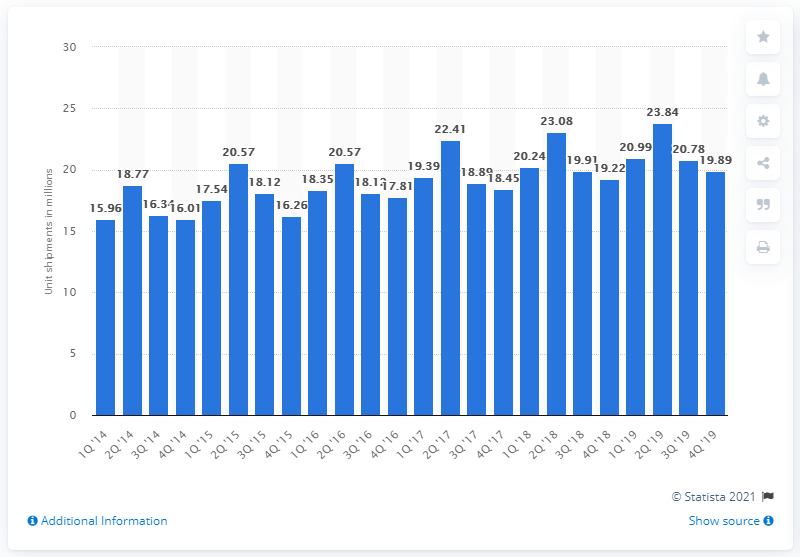Specify some key components in this picture. The forecast for unit shipments of major home appliances in the US in the first quarter of 2018 is expected to be 20.24. 